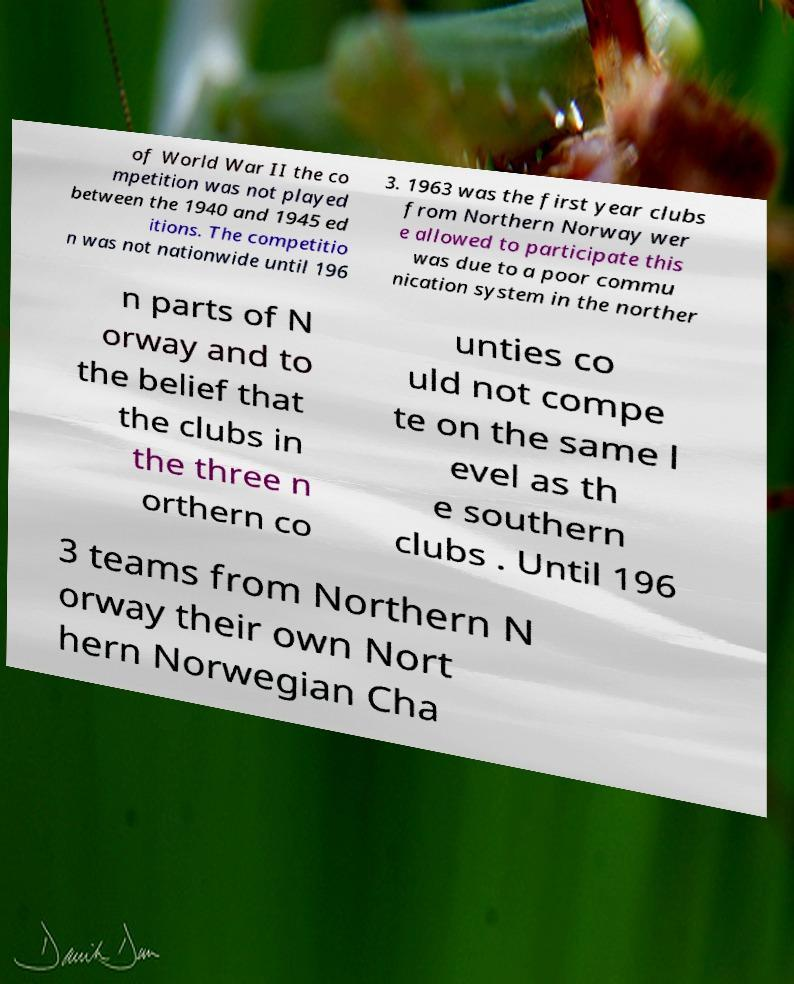Could you extract and type out the text from this image? of World War II the co mpetition was not played between the 1940 and 1945 ed itions. The competitio n was not nationwide until 196 3. 1963 was the first year clubs from Northern Norway wer e allowed to participate this was due to a poor commu nication system in the norther n parts of N orway and to the belief that the clubs in the three n orthern co unties co uld not compe te on the same l evel as th e southern clubs . Until 196 3 teams from Northern N orway their own Nort hern Norwegian Cha 